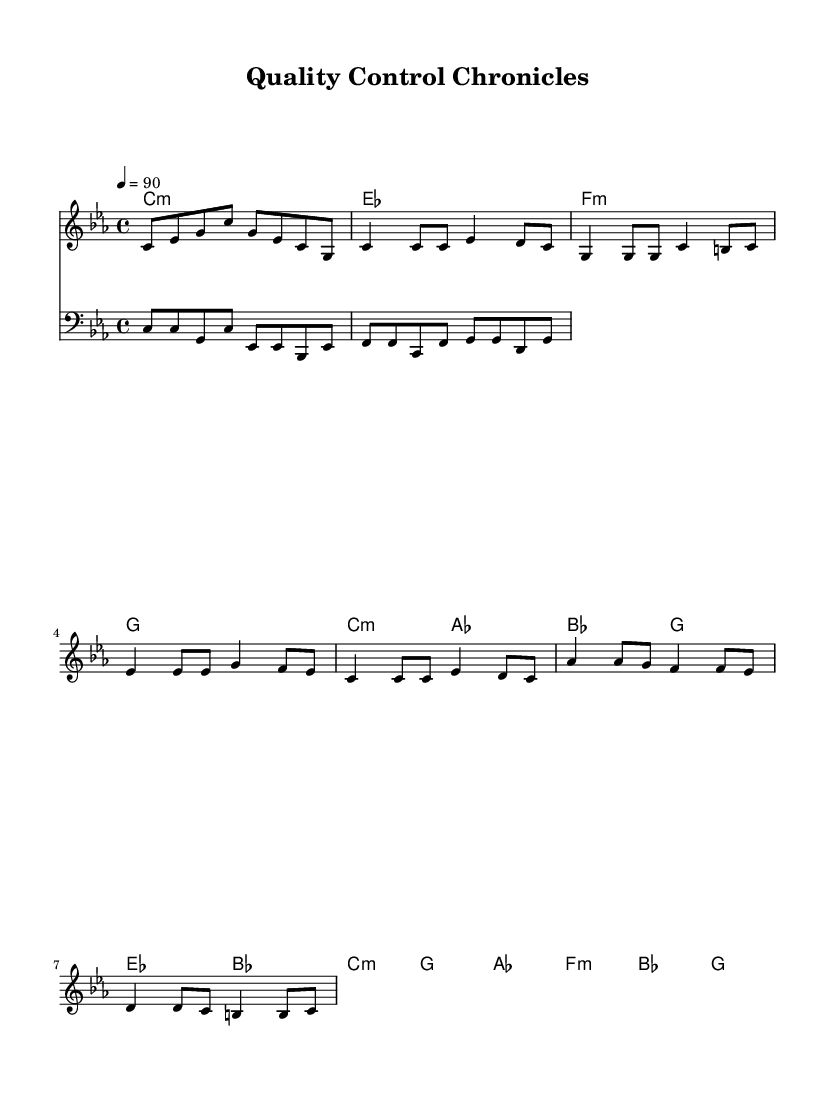What is the key signature of this music? The key signature is C minor, which has three flats (B flat, E flat, and A flat). This can be determined by looking at the key signature markings at the beginning of the sheet music.
Answer: C minor What is the time signature of this piece? The time signature is 4/4, which means there are four beats in each measure and the duration of each beat is a quarter note. This is indicated at the beginning of the score.
Answer: 4/4 What is the tempo marking of this piece? The tempo marking is 90 beats per minute, which is indicated by the tempo specification (in this case written as "4 = 90"). This indicates the speed at which the piece should be played.
Answer: 90 How many measures are there in the verse? The verse consists of two measures, as evidenced by the notation displayed in the corresponding section of the score. Measures are divided by vertical lines, making them easy to count.
Answer: 2 Which section features a chorus? The section labeled as the "Chorus" is clearly marked in the sheet music, indicating that this is where the chorus occurs. This labeling helps distinguish different musical parts throughout the piece.
Answer: Chorus What is the harmonic progression of the bridge? The harmonic progression of the bridge consists of two chords: A flat major (as) followed by F minor (f) and then B flat major (bes) followed by G major (g). This can be observed in the chord section of the score specifically for the bridge.
Answer: A flat major, F minor, B flat major, G major What is the primary theme of the lyrics as indicated by the verses? The lyrics depict a daily life narrative of a pharmaceutical administrator, focusing on the challenges and responsibilities within the quality control process. The combination of rhythmic flow and lyrical storytelling unique to rap supports this theme.
Answer: Daily life of a pharmaceutical administrator 